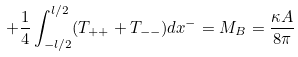<formula> <loc_0><loc_0><loc_500><loc_500>+ \frac { 1 } { 4 } \int ^ { l / 2 } _ { - l / 2 } ( T _ { + + } + T _ { - - } ) d x ^ { - } = M _ { B } = \frac { \kappa A } { 8 \pi }</formula> 